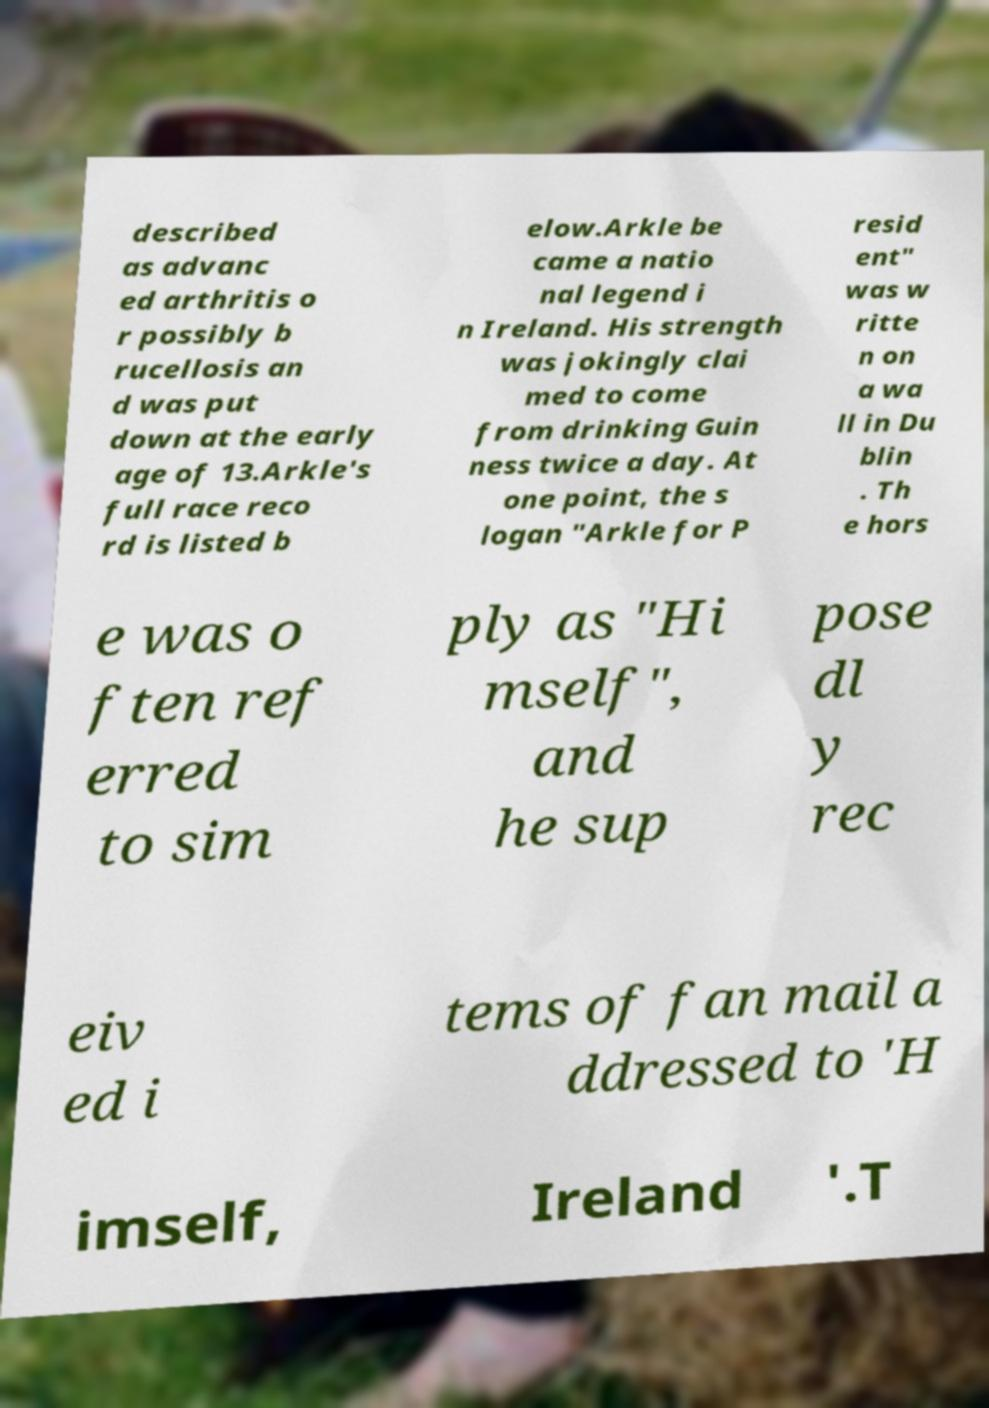For documentation purposes, I need the text within this image transcribed. Could you provide that? described as advanc ed arthritis o r possibly b rucellosis an d was put down at the early age of 13.Arkle's full race reco rd is listed b elow.Arkle be came a natio nal legend i n Ireland. His strength was jokingly clai med to come from drinking Guin ness twice a day. At one point, the s logan "Arkle for P resid ent" was w ritte n on a wa ll in Du blin . Th e hors e was o ften ref erred to sim ply as "Hi mself", and he sup pose dl y rec eiv ed i tems of fan mail a ddressed to 'H imself, Ireland '.T 